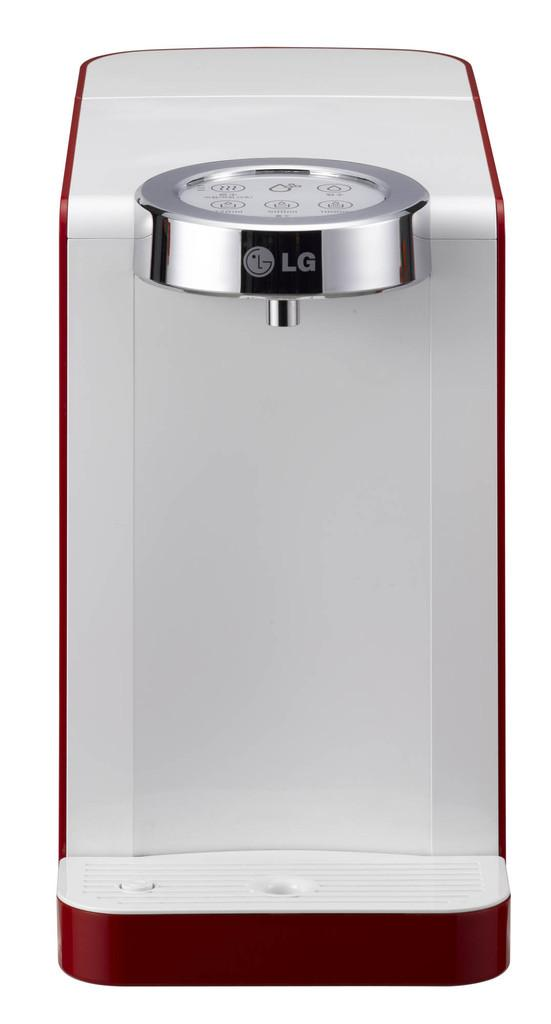<image>
Create a compact narrative representing the image presented. Many options are available on top of this LG product. 